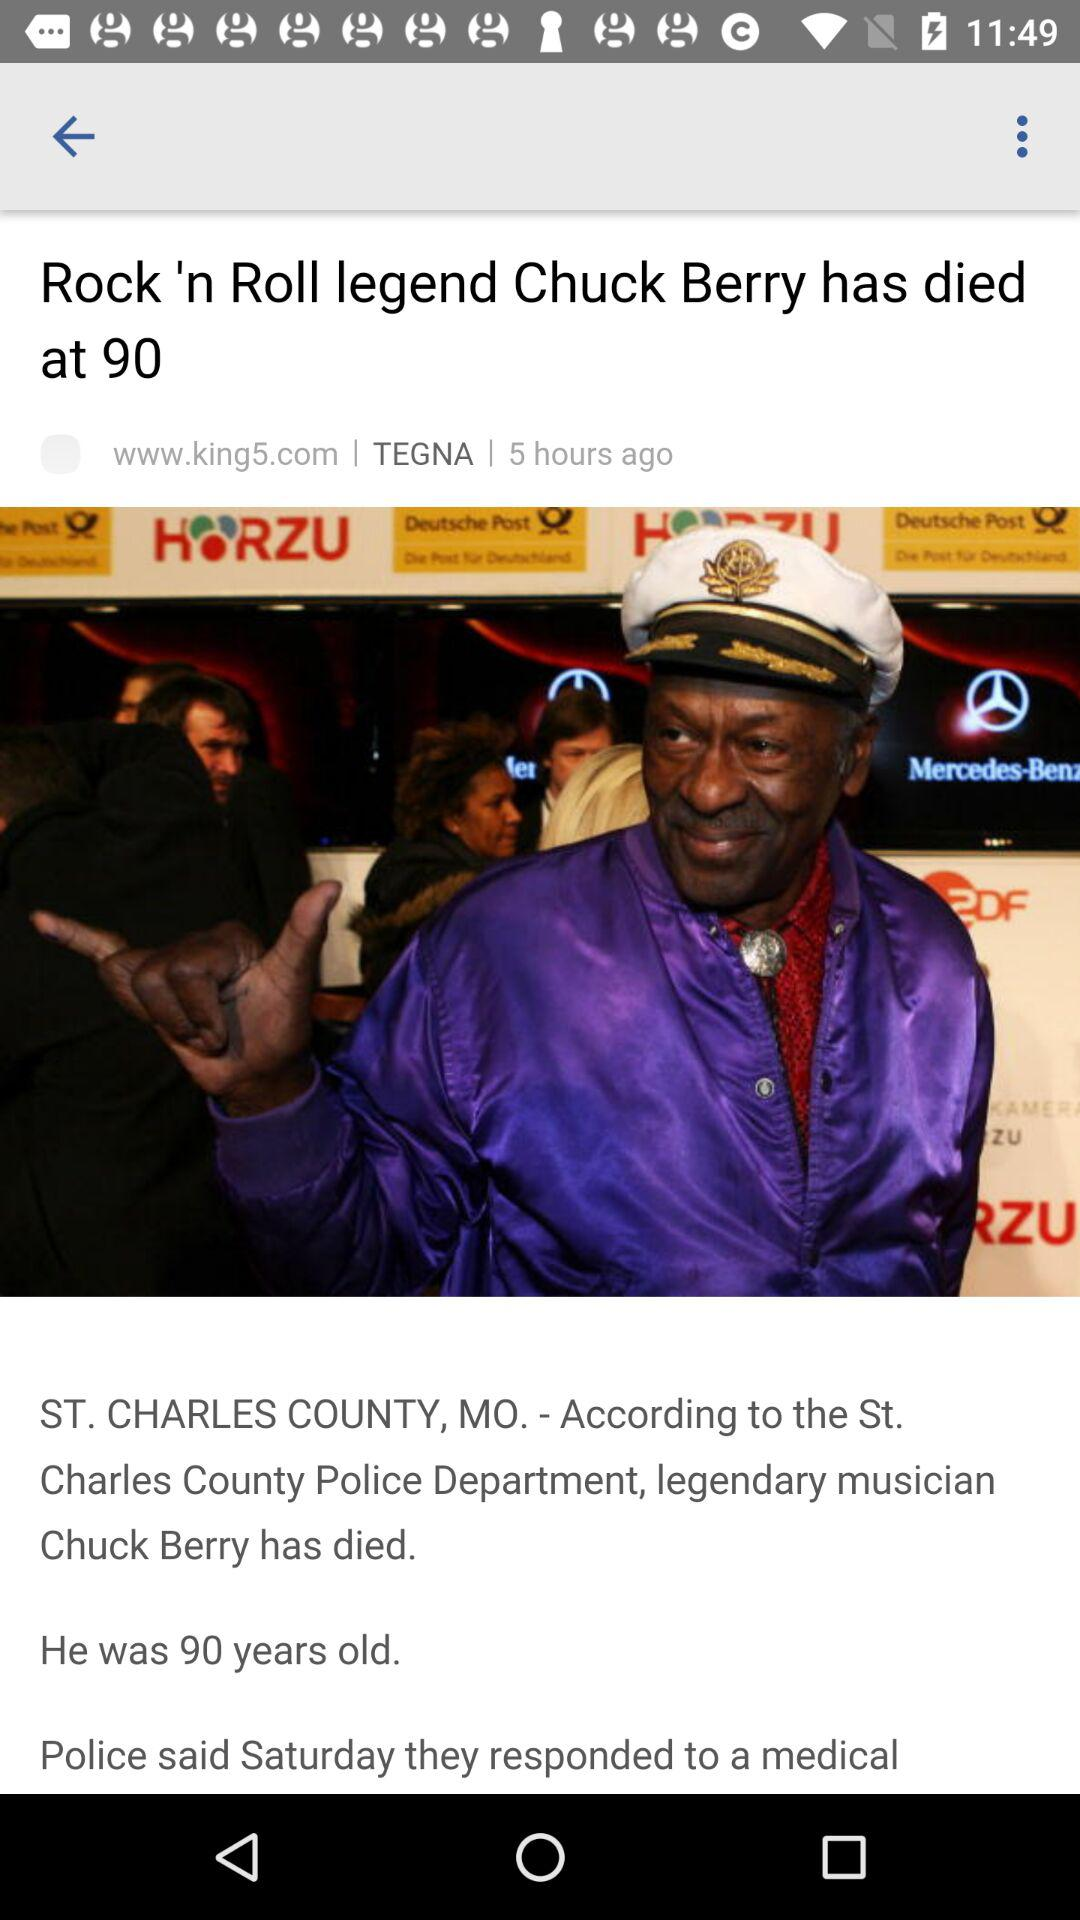How many hours ago did Chuck Berry die?
Answer the question using a single word or phrase. 5 